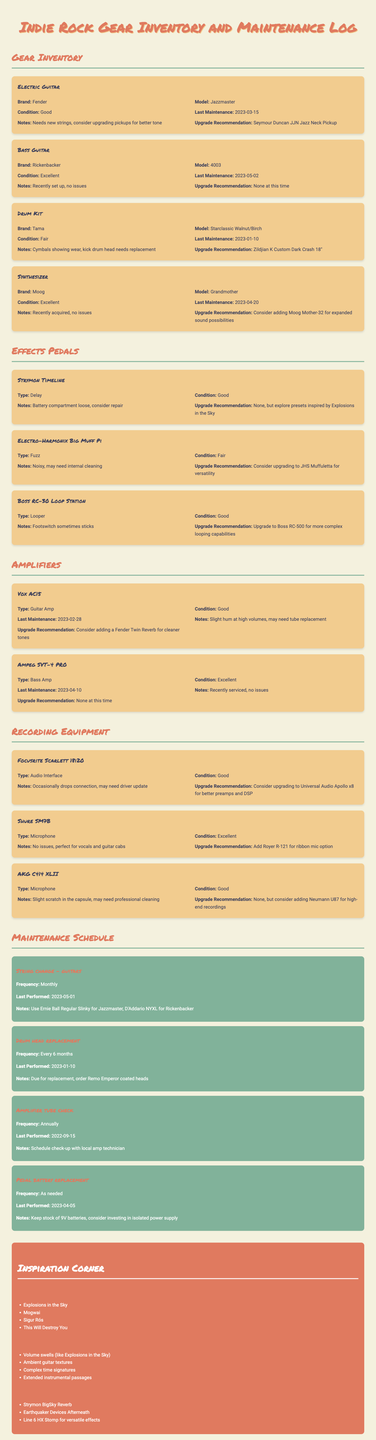What is the condition of the Fender Jazzmaster? The condition of the Fender Jazzmaster is listed in the gear inventory section.
Answer: Good When was the last maintenance for the Rickenbacker 4003? The last maintenance date is noted in the maintenance log for the bass guitar.
Answer: 2023-05-02 What upgrade is recommended for the Tama drum kit? The upgrade recommendation is mentioned in the inventory for the drum kit section.
Answer: Zildjian K Custom Dark Crash 18" Which effect pedal is noted as noisy? The condition and notes for each effects pedal provide this information.
Answer: Electro-Harmonix Big Muff Pi How often should guitar strings be changed? The frequency for changing strings is detailed in the maintenance schedule.
Answer: Monthly What is the suggested upgrade for the Focusrite Scarlett 18i20? The upgrade recommendation reflects suggested improvements for the audio interface.
Answer: Universal Audio Apollo x8 What maintenance task is due for the drum kit? The maintenance schedule indicates specific tasks and their timings for instruments.
Answer: Drum head replacement Who is suggested to study for inspiration in the genre? The "Inspiration Corner" lists bands to study that might influence the music style.
Answer: Explosions in the Sky What type of guitar amp is the Vox AC15? The type of amplifier is categorized in the amplifier section of the inventory.
Answer: Guitar Amp 